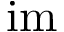<formula> <loc_0><loc_0><loc_500><loc_500>i m</formula> 